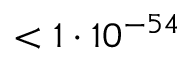Convert formula to latex. <formula><loc_0><loc_0><loc_500><loc_500>< 1 \cdot 1 0 ^ { - 5 4 }</formula> 